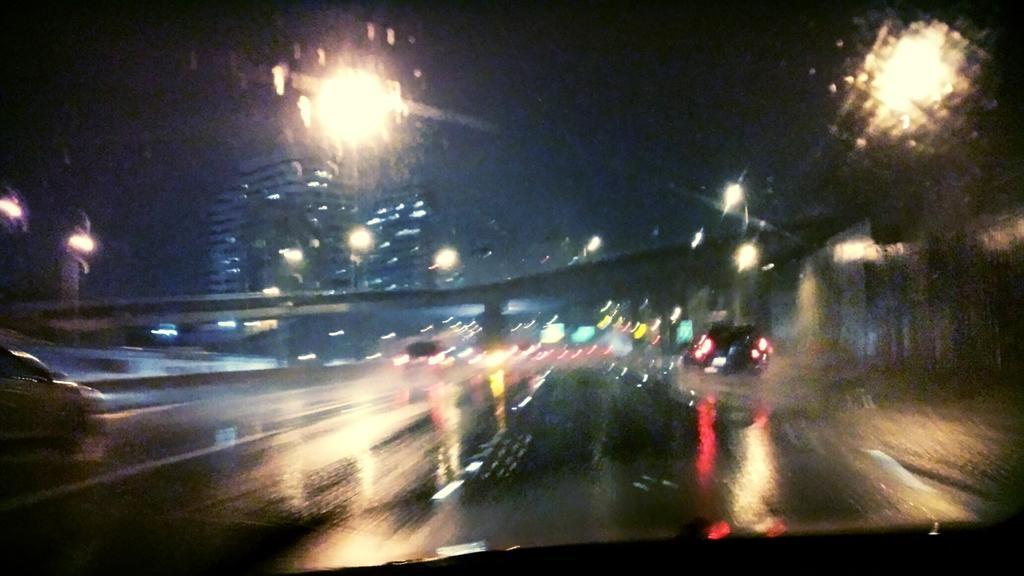Describe this image in one or two sentences. In this image I can see few vehicles on the road, background I can see the bridge, few buildings, few lights and the sky is in black color. 